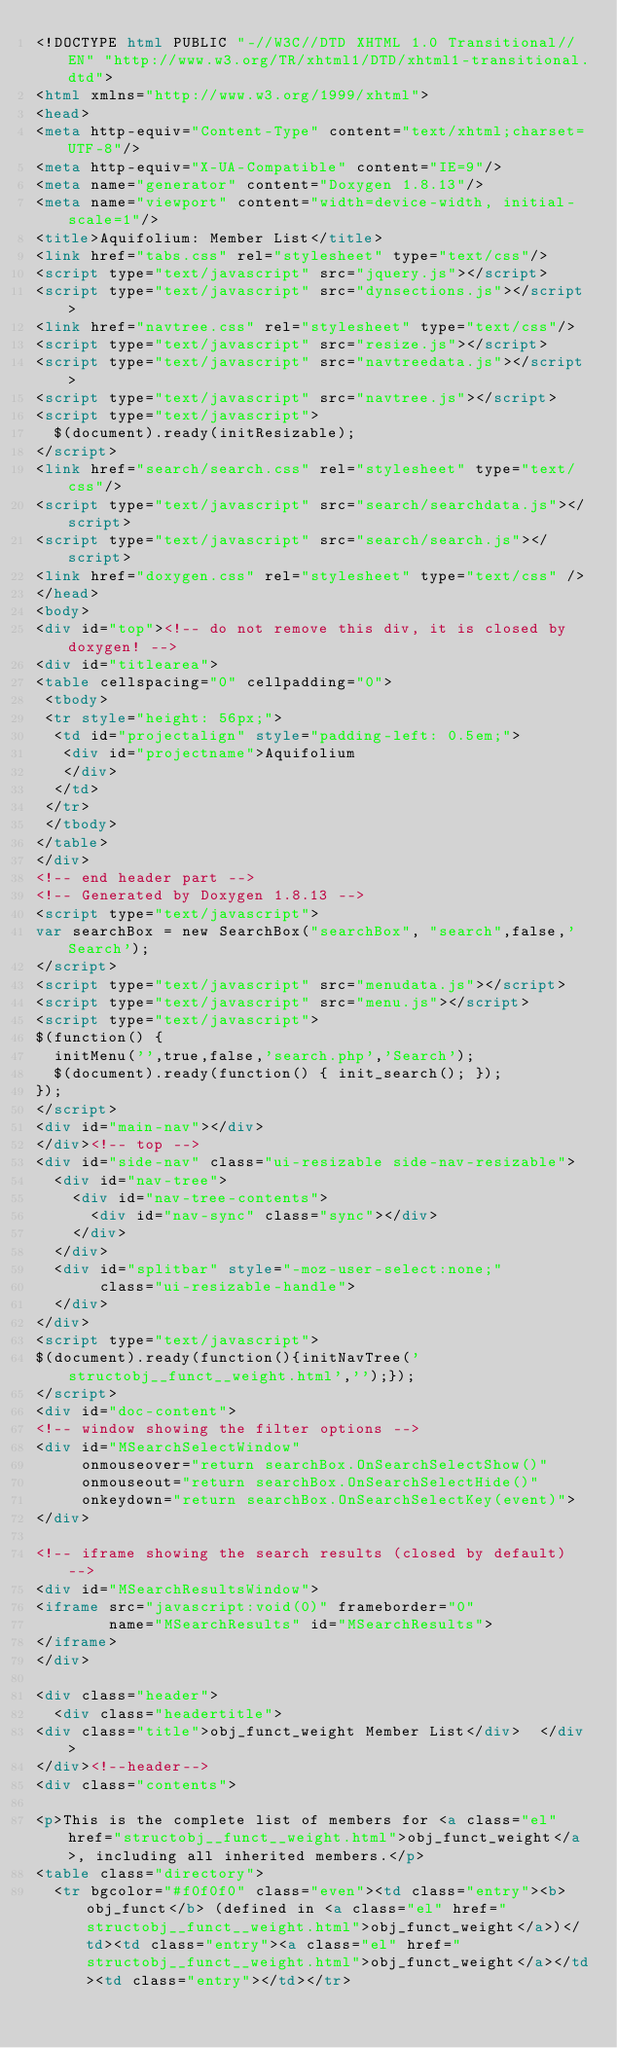Convert code to text. <code><loc_0><loc_0><loc_500><loc_500><_HTML_><!DOCTYPE html PUBLIC "-//W3C//DTD XHTML 1.0 Transitional//EN" "http://www.w3.org/TR/xhtml1/DTD/xhtml1-transitional.dtd">
<html xmlns="http://www.w3.org/1999/xhtml">
<head>
<meta http-equiv="Content-Type" content="text/xhtml;charset=UTF-8"/>
<meta http-equiv="X-UA-Compatible" content="IE=9"/>
<meta name="generator" content="Doxygen 1.8.13"/>
<meta name="viewport" content="width=device-width, initial-scale=1"/>
<title>Aquifolium: Member List</title>
<link href="tabs.css" rel="stylesheet" type="text/css"/>
<script type="text/javascript" src="jquery.js"></script>
<script type="text/javascript" src="dynsections.js"></script>
<link href="navtree.css" rel="stylesheet" type="text/css"/>
<script type="text/javascript" src="resize.js"></script>
<script type="text/javascript" src="navtreedata.js"></script>
<script type="text/javascript" src="navtree.js"></script>
<script type="text/javascript">
  $(document).ready(initResizable);
</script>
<link href="search/search.css" rel="stylesheet" type="text/css"/>
<script type="text/javascript" src="search/searchdata.js"></script>
<script type="text/javascript" src="search/search.js"></script>
<link href="doxygen.css" rel="stylesheet" type="text/css" />
</head>
<body>
<div id="top"><!-- do not remove this div, it is closed by doxygen! -->
<div id="titlearea">
<table cellspacing="0" cellpadding="0">
 <tbody>
 <tr style="height: 56px;">
  <td id="projectalign" style="padding-left: 0.5em;">
   <div id="projectname">Aquifolium
   </div>
  </td>
 </tr>
 </tbody>
</table>
</div>
<!-- end header part -->
<!-- Generated by Doxygen 1.8.13 -->
<script type="text/javascript">
var searchBox = new SearchBox("searchBox", "search",false,'Search');
</script>
<script type="text/javascript" src="menudata.js"></script>
<script type="text/javascript" src="menu.js"></script>
<script type="text/javascript">
$(function() {
  initMenu('',true,false,'search.php','Search');
  $(document).ready(function() { init_search(); });
});
</script>
<div id="main-nav"></div>
</div><!-- top -->
<div id="side-nav" class="ui-resizable side-nav-resizable">
  <div id="nav-tree">
    <div id="nav-tree-contents">
      <div id="nav-sync" class="sync"></div>
    </div>
  </div>
  <div id="splitbar" style="-moz-user-select:none;" 
       class="ui-resizable-handle">
  </div>
</div>
<script type="text/javascript">
$(document).ready(function(){initNavTree('structobj__funct__weight.html','');});
</script>
<div id="doc-content">
<!-- window showing the filter options -->
<div id="MSearchSelectWindow"
     onmouseover="return searchBox.OnSearchSelectShow()"
     onmouseout="return searchBox.OnSearchSelectHide()"
     onkeydown="return searchBox.OnSearchSelectKey(event)">
</div>

<!-- iframe showing the search results (closed by default) -->
<div id="MSearchResultsWindow">
<iframe src="javascript:void(0)" frameborder="0" 
        name="MSearchResults" id="MSearchResults">
</iframe>
</div>

<div class="header">
  <div class="headertitle">
<div class="title">obj_funct_weight Member List</div>  </div>
</div><!--header-->
<div class="contents">

<p>This is the complete list of members for <a class="el" href="structobj__funct__weight.html">obj_funct_weight</a>, including all inherited members.</p>
<table class="directory">
  <tr bgcolor="#f0f0f0" class="even"><td class="entry"><b>obj_funct</b> (defined in <a class="el" href="structobj__funct__weight.html">obj_funct_weight</a>)</td><td class="entry"><a class="el" href="structobj__funct__weight.html">obj_funct_weight</a></td><td class="entry"></td></tr></code> 